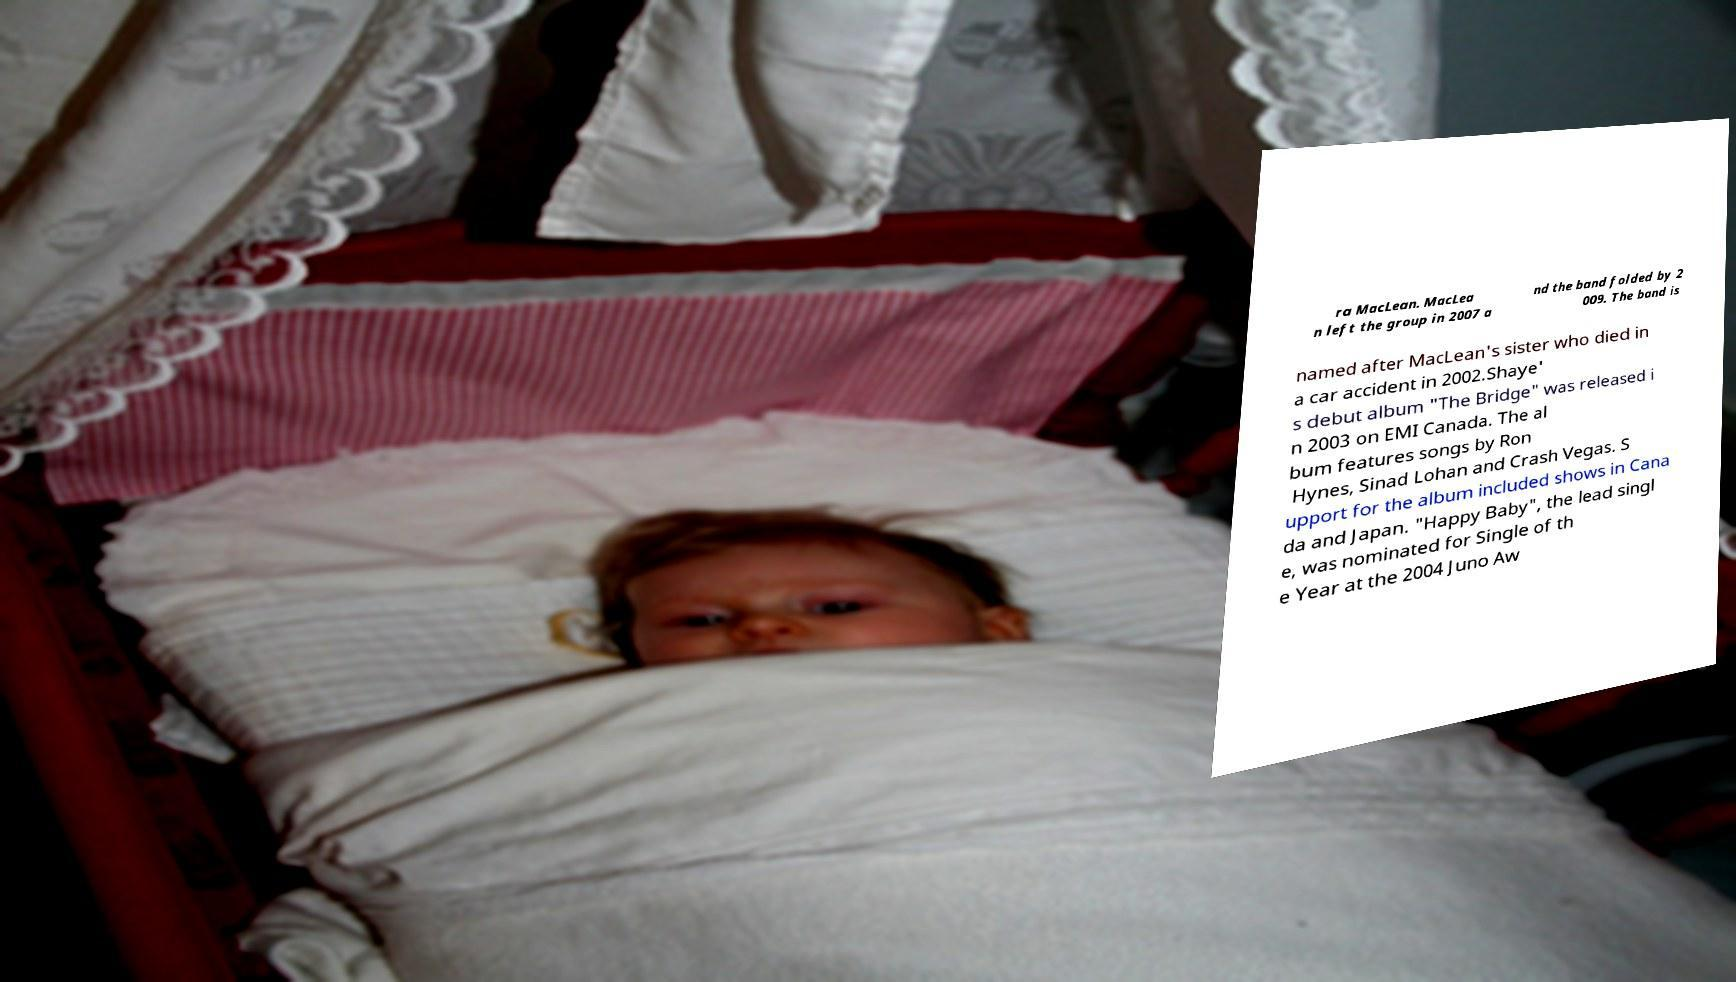Could you extract and type out the text from this image? ra MacLean. MacLea n left the group in 2007 a nd the band folded by 2 009. The band is named after MacLean's sister who died in a car accident in 2002.Shaye' s debut album "The Bridge" was released i n 2003 on EMI Canada. The al bum features songs by Ron Hynes, Sinad Lohan and Crash Vegas. S upport for the album included shows in Cana da and Japan. "Happy Baby", the lead singl e, was nominated for Single of th e Year at the 2004 Juno Aw 